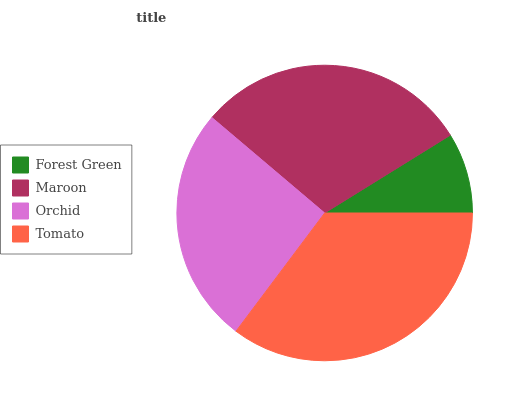Is Forest Green the minimum?
Answer yes or no. Yes. Is Tomato the maximum?
Answer yes or no. Yes. Is Maroon the minimum?
Answer yes or no. No. Is Maroon the maximum?
Answer yes or no. No. Is Maroon greater than Forest Green?
Answer yes or no. Yes. Is Forest Green less than Maroon?
Answer yes or no. Yes. Is Forest Green greater than Maroon?
Answer yes or no. No. Is Maroon less than Forest Green?
Answer yes or no. No. Is Maroon the high median?
Answer yes or no. Yes. Is Orchid the low median?
Answer yes or no. Yes. Is Tomato the high median?
Answer yes or no. No. Is Maroon the low median?
Answer yes or no. No. 